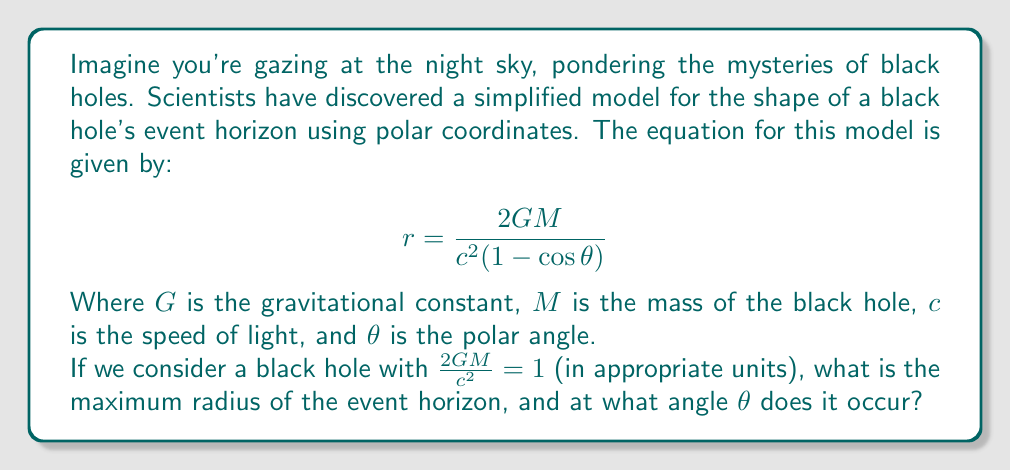Provide a solution to this math problem. Let's approach this step-by-step:

1) First, we simplify our equation by substituting $\frac{2GM}{c^2} = 1$:

   $$r = \frac{1}{1 - \cos\theta}$$

2) To find the maximum radius, we need to find where the derivative of $r$ with respect to $\theta$ is zero. Let's calculate this derivative:

   $$\frac{dr}{d\theta} = \frac{\sin\theta}{(1-\cos\theta)^2}$$

3) Setting this equal to zero:

   $$\frac{\sin\theta}{(1-\cos\theta)^2} = 0$$

4) This equation is satisfied when $\sin\theta = 0$, which occurs at $\theta = 0$, $\pi$, $2\pi$, etc.

5) However, we need to be careful. At $\theta = 0$, $\cos\theta = 1$, which would make our denominator zero. This isn't a valid solution.

6) At $\theta = \pi$, $\cos\theta = -1$. This is a valid solution.

7) Substituting $\theta = \pi$ into our original equation:

   $$r_{max} = \frac{1}{1 - \cos\pi} = \frac{1}{1 - (-1)} = \frac{1}{2}$$

Thus, the maximum radius occurs at $\theta = \pi$ (or 180°), and the value of this maximum radius is $\frac{1}{2}$.
Answer: The maximum radius of the event horizon is $\frac{1}{2}$, occurring at $\theta = \pi$ radians (180°). 